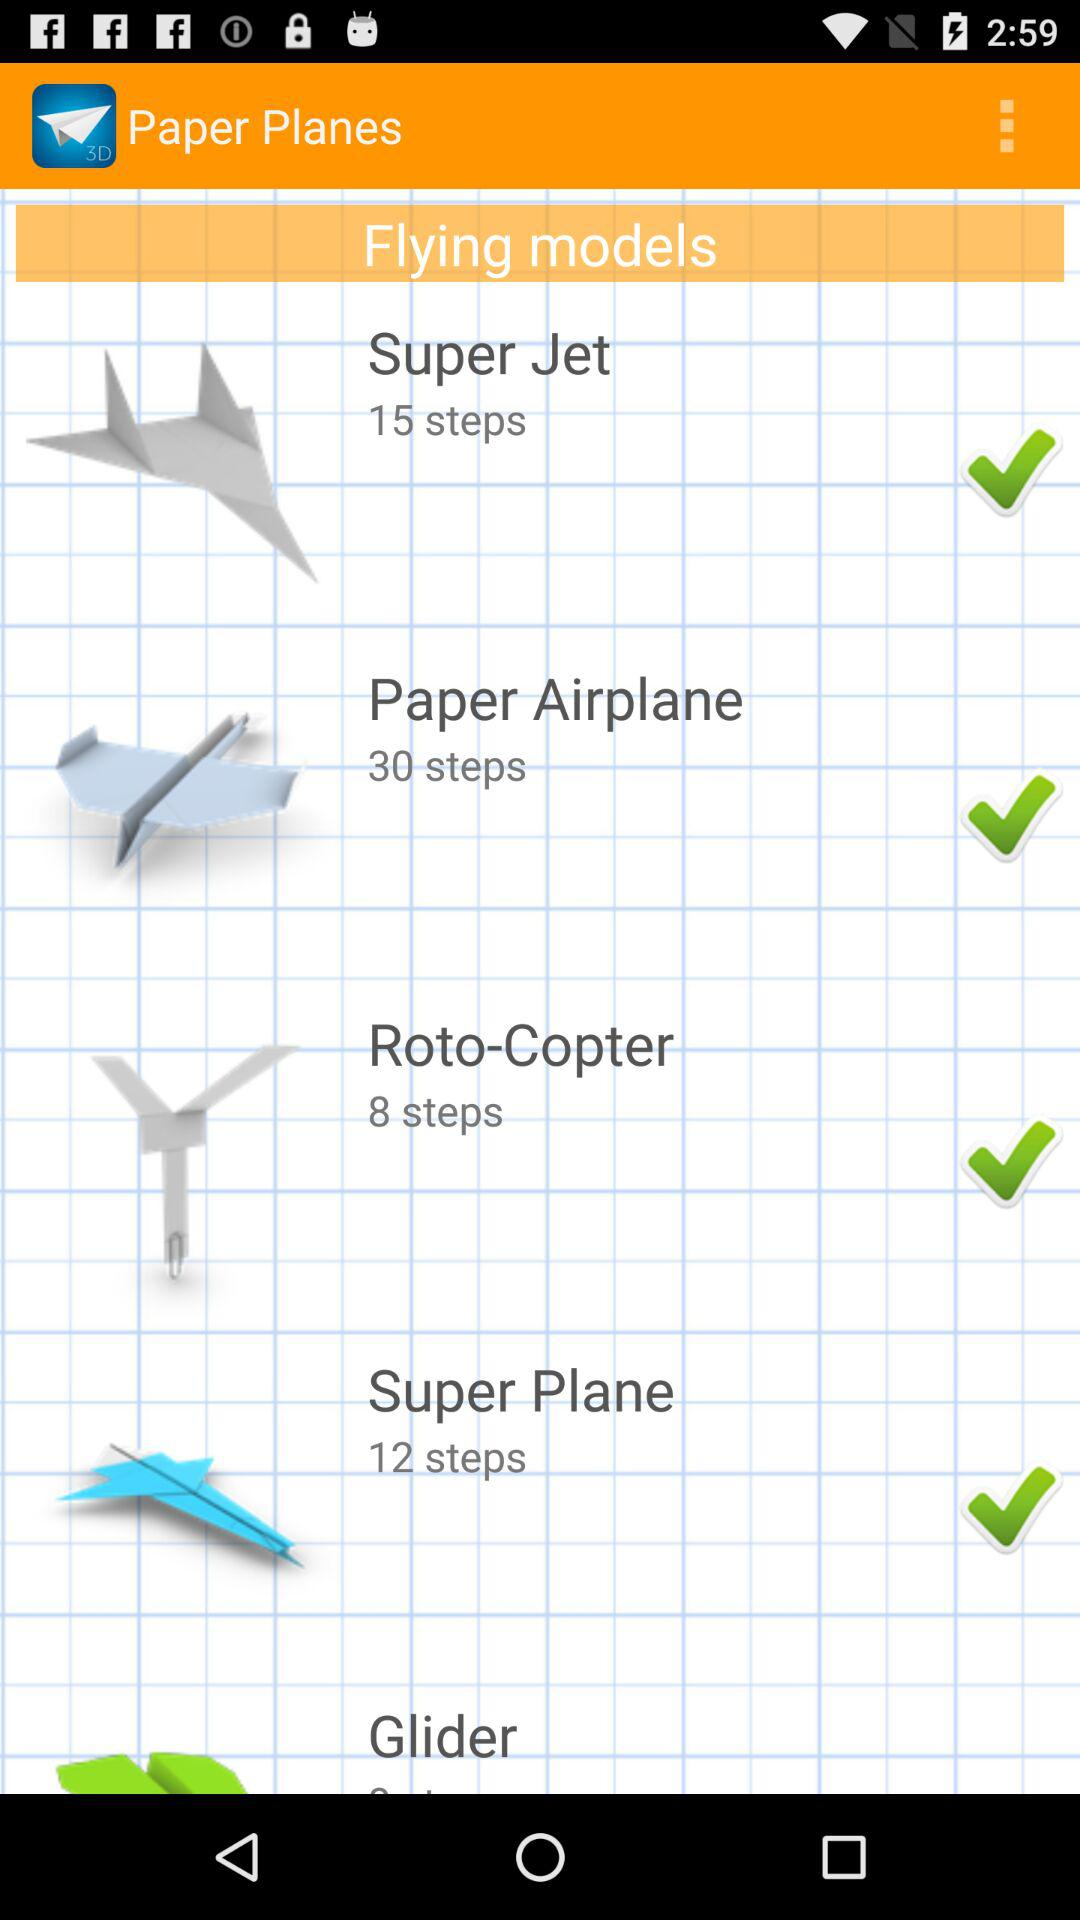How many steps does it take to make the "Paper Airplane"? It takes 30 steps to make the "Paper Airplane". 